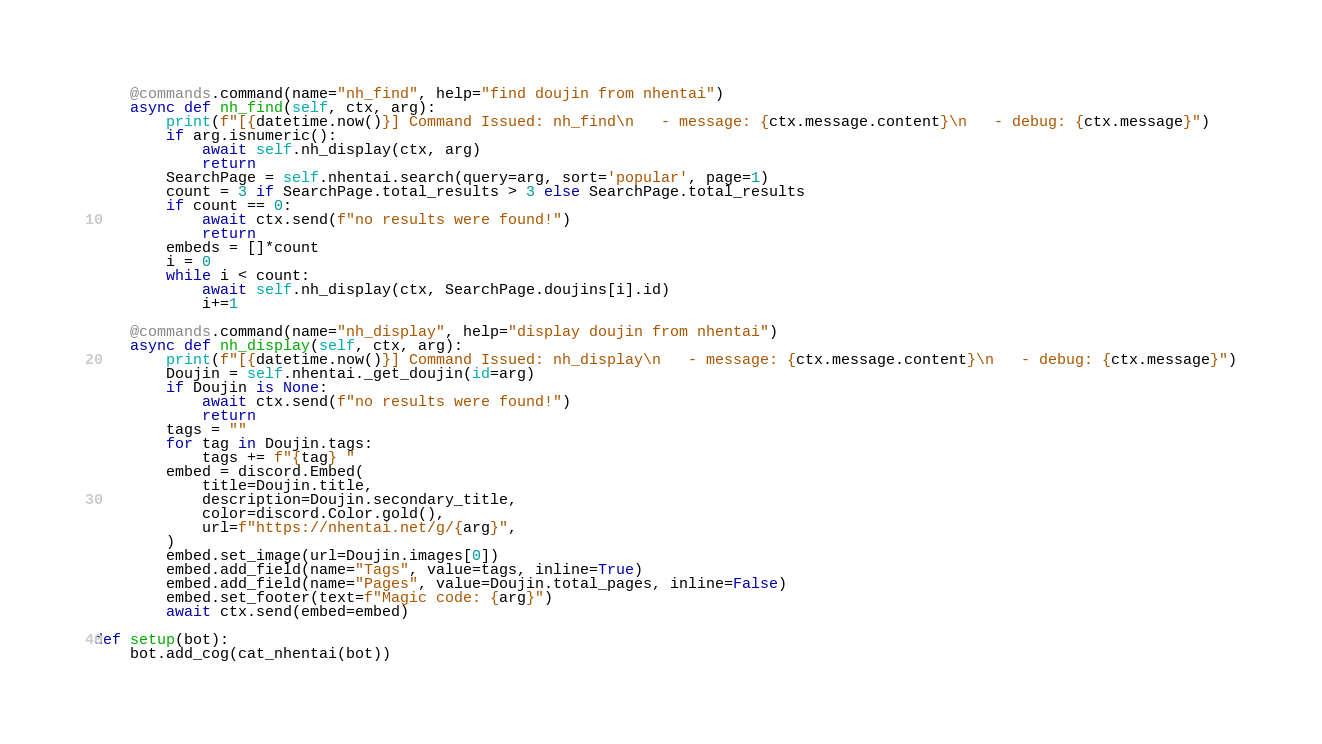Convert code to text. <code><loc_0><loc_0><loc_500><loc_500><_Python_>
    @commands.command(name="nh_find", help="find doujin from nhentai")
    async def nh_find(self, ctx, arg):
        print(f"[{datetime.now()}] Command Issued: nh_find\n   - message: {ctx.message.content}\n   - debug: {ctx.message}")
        if arg.isnumeric():
            await self.nh_display(ctx, arg)
            return
        SearchPage = self.nhentai.search(query=arg, sort='popular', page=1)
        count = 3 if SearchPage.total_results > 3 else SearchPage.total_results
        if count == 0:
            await ctx.send(f"no results were found!")
            return
        embeds = []*count
        i = 0
        while i < count:
            await self.nh_display(ctx, SearchPage.doujins[i].id)
            i+=1

    @commands.command(name="nh_display", help="display doujin from nhentai")
    async def nh_display(self, ctx, arg):
        print(f"[{datetime.now()}] Command Issued: nh_display\n   - message: {ctx.message.content}\n   - debug: {ctx.message}")
        Doujin = self.nhentai._get_doujin(id=arg)
        if Doujin is None:
            await ctx.send(f"no results were found!")
            return
        tags = ""
        for tag in Doujin.tags:
            tags += f"{tag} "
        embed = discord.Embed(
            title=Doujin.title,
            description=Doujin.secondary_title,
            color=discord.Color.gold(),
            url=f"https://nhentai.net/g/{arg}",
        )
        embed.set_image(url=Doujin.images[0])
        embed.add_field(name="Tags", value=tags, inline=True)
        embed.add_field(name="Pages", value=Doujin.total_pages, inline=False)
        embed.set_footer(text=f"Magic code: {arg}")
        await ctx.send(embed=embed)

def setup(bot):
    bot.add_cog(cat_nhentai(bot))</code> 